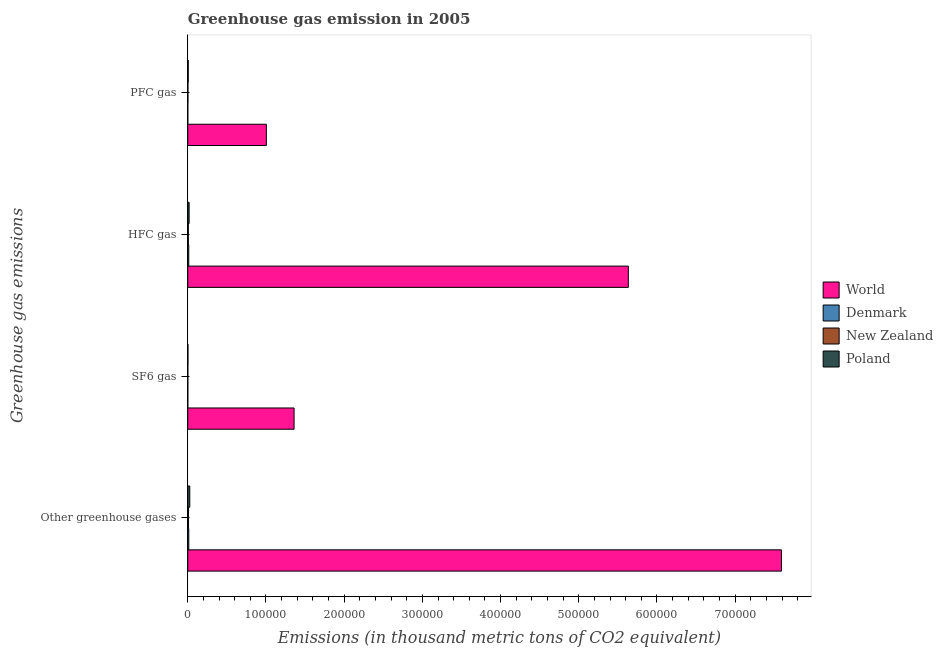How many groups of bars are there?
Offer a very short reply. 4. How many bars are there on the 4th tick from the top?
Provide a succinct answer. 4. What is the label of the 2nd group of bars from the top?
Offer a very short reply. HFC gas. What is the emission of sf6 gas in World?
Provide a succinct answer. 1.36e+05. Across all countries, what is the maximum emission of pfc gas?
Keep it short and to the point. 1.01e+05. Across all countries, what is the minimum emission of hfc gas?
Your answer should be compact. 721.7. In which country was the emission of hfc gas minimum?
Ensure brevity in your answer.  New Zealand. What is the total emission of hfc gas in the graph?
Give a very brief answer. 5.67e+05. What is the difference between the emission of greenhouse gases in New Zealand and that in Poland?
Make the answer very short. -1581.2. What is the difference between the emission of pfc gas in World and the emission of greenhouse gases in Denmark?
Offer a very short reply. 9.92e+04. What is the average emission of sf6 gas per country?
Your answer should be compact. 3.41e+04. What is the difference between the emission of greenhouse gases and emission of sf6 gas in Denmark?
Make the answer very short. 1271. What is the ratio of the emission of sf6 gas in Denmark to that in Poland?
Ensure brevity in your answer.  0.14. Is the emission of hfc gas in New Zealand less than that in Denmark?
Ensure brevity in your answer.  Yes. What is the difference between the highest and the second highest emission of pfc gas?
Provide a short and direct response. 9.99e+04. What is the difference between the highest and the lowest emission of sf6 gas?
Keep it short and to the point. 1.36e+05. In how many countries, is the emission of hfc gas greater than the average emission of hfc gas taken over all countries?
Keep it short and to the point. 1. Is the sum of the emission of greenhouse gases in New Zealand and Denmark greater than the maximum emission of hfc gas across all countries?
Your response must be concise. No. What does the 1st bar from the top in PFC gas represents?
Your response must be concise. Poland. How many bars are there?
Offer a very short reply. 16. Are all the bars in the graph horizontal?
Make the answer very short. Yes. Does the graph contain any zero values?
Make the answer very short. No. How many legend labels are there?
Make the answer very short. 4. How are the legend labels stacked?
Offer a terse response. Vertical. What is the title of the graph?
Your answer should be very brief. Greenhouse gas emission in 2005. Does "Sub-Saharan Africa (developing only)" appear as one of the legend labels in the graph?
Keep it short and to the point. No. What is the label or title of the X-axis?
Ensure brevity in your answer.  Emissions (in thousand metric tons of CO2 equivalent). What is the label or title of the Y-axis?
Your response must be concise. Greenhouse gas emissions. What is the Emissions (in thousand metric tons of CO2 equivalent) in World in Other greenhouse gases?
Your answer should be very brief. 7.59e+05. What is the Emissions (in thousand metric tons of CO2 equivalent) of Denmark in Other greenhouse gases?
Offer a very short reply. 1302.5. What is the Emissions (in thousand metric tons of CO2 equivalent) in New Zealand in Other greenhouse gases?
Make the answer very short. 966.7. What is the Emissions (in thousand metric tons of CO2 equivalent) of Poland in Other greenhouse gases?
Make the answer very short. 2547.9. What is the Emissions (in thousand metric tons of CO2 equivalent) of World in SF6 gas?
Make the answer very short. 1.36e+05. What is the Emissions (in thousand metric tons of CO2 equivalent) in Denmark in SF6 gas?
Provide a succinct answer. 31.5. What is the Emissions (in thousand metric tons of CO2 equivalent) of New Zealand in SF6 gas?
Your response must be concise. 53.4. What is the Emissions (in thousand metric tons of CO2 equivalent) in Poland in SF6 gas?
Your answer should be compact. 218.5. What is the Emissions (in thousand metric tons of CO2 equivalent) in World in HFC gas?
Ensure brevity in your answer.  5.63e+05. What is the Emissions (in thousand metric tons of CO2 equivalent) of Denmark in HFC gas?
Provide a succinct answer. 1249.5. What is the Emissions (in thousand metric tons of CO2 equivalent) in New Zealand in HFC gas?
Offer a terse response. 721.7. What is the Emissions (in thousand metric tons of CO2 equivalent) of Poland in HFC gas?
Your response must be concise. 1736.7. What is the Emissions (in thousand metric tons of CO2 equivalent) of World in PFC gas?
Ensure brevity in your answer.  1.01e+05. What is the Emissions (in thousand metric tons of CO2 equivalent) in New Zealand in PFC gas?
Ensure brevity in your answer.  191.6. What is the Emissions (in thousand metric tons of CO2 equivalent) in Poland in PFC gas?
Provide a succinct answer. 592.7. Across all Greenhouse gas emissions, what is the maximum Emissions (in thousand metric tons of CO2 equivalent) in World?
Make the answer very short. 7.59e+05. Across all Greenhouse gas emissions, what is the maximum Emissions (in thousand metric tons of CO2 equivalent) in Denmark?
Provide a short and direct response. 1302.5. Across all Greenhouse gas emissions, what is the maximum Emissions (in thousand metric tons of CO2 equivalent) in New Zealand?
Provide a succinct answer. 966.7. Across all Greenhouse gas emissions, what is the maximum Emissions (in thousand metric tons of CO2 equivalent) in Poland?
Provide a short and direct response. 2547.9. Across all Greenhouse gas emissions, what is the minimum Emissions (in thousand metric tons of CO2 equivalent) of World?
Give a very brief answer. 1.01e+05. Across all Greenhouse gas emissions, what is the minimum Emissions (in thousand metric tons of CO2 equivalent) of Denmark?
Offer a terse response. 21.5. Across all Greenhouse gas emissions, what is the minimum Emissions (in thousand metric tons of CO2 equivalent) in New Zealand?
Make the answer very short. 53.4. Across all Greenhouse gas emissions, what is the minimum Emissions (in thousand metric tons of CO2 equivalent) of Poland?
Make the answer very short. 218.5. What is the total Emissions (in thousand metric tons of CO2 equivalent) in World in the graph?
Make the answer very short. 1.56e+06. What is the total Emissions (in thousand metric tons of CO2 equivalent) in Denmark in the graph?
Keep it short and to the point. 2605. What is the total Emissions (in thousand metric tons of CO2 equivalent) of New Zealand in the graph?
Keep it short and to the point. 1933.4. What is the total Emissions (in thousand metric tons of CO2 equivalent) in Poland in the graph?
Offer a very short reply. 5095.8. What is the difference between the Emissions (in thousand metric tons of CO2 equivalent) in World in Other greenhouse gases and that in SF6 gas?
Ensure brevity in your answer.  6.23e+05. What is the difference between the Emissions (in thousand metric tons of CO2 equivalent) of Denmark in Other greenhouse gases and that in SF6 gas?
Offer a very short reply. 1271. What is the difference between the Emissions (in thousand metric tons of CO2 equivalent) of New Zealand in Other greenhouse gases and that in SF6 gas?
Your response must be concise. 913.3. What is the difference between the Emissions (in thousand metric tons of CO2 equivalent) of Poland in Other greenhouse gases and that in SF6 gas?
Offer a terse response. 2329.4. What is the difference between the Emissions (in thousand metric tons of CO2 equivalent) of World in Other greenhouse gases and that in HFC gas?
Provide a succinct answer. 1.96e+05. What is the difference between the Emissions (in thousand metric tons of CO2 equivalent) in New Zealand in Other greenhouse gases and that in HFC gas?
Make the answer very short. 245. What is the difference between the Emissions (in thousand metric tons of CO2 equivalent) in Poland in Other greenhouse gases and that in HFC gas?
Your answer should be compact. 811.2. What is the difference between the Emissions (in thousand metric tons of CO2 equivalent) of World in Other greenhouse gases and that in PFC gas?
Your answer should be compact. 6.59e+05. What is the difference between the Emissions (in thousand metric tons of CO2 equivalent) of Denmark in Other greenhouse gases and that in PFC gas?
Offer a very short reply. 1281. What is the difference between the Emissions (in thousand metric tons of CO2 equivalent) in New Zealand in Other greenhouse gases and that in PFC gas?
Provide a short and direct response. 775.1. What is the difference between the Emissions (in thousand metric tons of CO2 equivalent) of Poland in Other greenhouse gases and that in PFC gas?
Your response must be concise. 1955.2. What is the difference between the Emissions (in thousand metric tons of CO2 equivalent) of World in SF6 gas and that in HFC gas?
Your response must be concise. -4.27e+05. What is the difference between the Emissions (in thousand metric tons of CO2 equivalent) in Denmark in SF6 gas and that in HFC gas?
Provide a succinct answer. -1218. What is the difference between the Emissions (in thousand metric tons of CO2 equivalent) in New Zealand in SF6 gas and that in HFC gas?
Provide a succinct answer. -668.3. What is the difference between the Emissions (in thousand metric tons of CO2 equivalent) of Poland in SF6 gas and that in HFC gas?
Your answer should be compact. -1518.2. What is the difference between the Emissions (in thousand metric tons of CO2 equivalent) of World in SF6 gas and that in PFC gas?
Offer a very short reply. 3.54e+04. What is the difference between the Emissions (in thousand metric tons of CO2 equivalent) in New Zealand in SF6 gas and that in PFC gas?
Offer a very short reply. -138.2. What is the difference between the Emissions (in thousand metric tons of CO2 equivalent) of Poland in SF6 gas and that in PFC gas?
Your answer should be very brief. -374.2. What is the difference between the Emissions (in thousand metric tons of CO2 equivalent) of World in HFC gas and that in PFC gas?
Offer a very short reply. 4.63e+05. What is the difference between the Emissions (in thousand metric tons of CO2 equivalent) in Denmark in HFC gas and that in PFC gas?
Offer a very short reply. 1228. What is the difference between the Emissions (in thousand metric tons of CO2 equivalent) in New Zealand in HFC gas and that in PFC gas?
Your answer should be compact. 530.1. What is the difference between the Emissions (in thousand metric tons of CO2 equivalent) in Poland in HFC gas and that in PFC gas?
Offer a terse response. 1144. What is the difference between the Emissions (in thousand metric tons of CO2 equivalent) in World in Other greenhouse gases and the Emissions (in thousand metric tons of CO2 equivalent) in Denmark in SF6 gas?
Your response must be concise. 7.59e+05. What is the difference between the Emissions (in thousand metric tons of CO2 equivalent) of World in Other greenhouse gases and the Emissions (in thousand metric tons of CO2 equivalent) of New Zealand in SF6 gas?
Your answer should be compact. 7.59e+05. What is the difference between the Emissions (in thousand metric tons of CO2 equivalent) in World in Other greenhouse gases and the Emissions (in thousand metric tons of CO2 equivalent) in Poland in SF6 gas?
Ensure brevity in your answer.  7.59e+05. What is the difference between the Emissions (in thousand metric tons of CO2 equivalent) in Denmark in Other greenhouse gases and the Emissions (in thousand metric tons of CO2 equivalent) in New Zealand in SF6 gas?
Offer a very short reply. 1249.1. What is the difference between the Emissions (in thousand metric tons of CO2 equivalent) in Denmark in Other greenhouse gases and the Emissions (in thousand metric tons of CO2 equivalent) in Poland in SF6 gas?
Give a very brief answer. 1084. What is the difference between the Emissions (in thousand metric tons of CO2 equivalent) in New Zealand in Other greenhouse gases and the Emissions (in thousand metric tons of CO2 equivalent) in Poland in SF6 gas?
Provide a short and direct response. 748.2. What is the difference between the Emissions (in thousand metric tons of CO2 equivalent) of World in Other greenhouse gases and the Emissions (in thousand metric tons of CO2 equivalent) of Denmark in HFC gas?
Ensure brevity in your answer.  7.58e+05. What is the difference between the Emissions (in thousand metric tons of CO2 equivalent) of World in Other greenhouse gases and the Emissions (in thousand metric tons of CO2 equivalent) of New Zealand in HFC gas?
Your answer should be compact. 7.58e+05. What is the difference between the Emissions (in thousand metric tons of CO2 equivalent) of World in Other greenhouse gases and the Emissions (in thousand metric tons of CO2 equivalent) of Poland in HFC gas?
Make the answer very short. 7.57e+05. What is the difference between the Emissions (in thousand metric tons of CO2 equivalent) in Denmark in Other greenhouse gases and the Emissions (in thousand metric tons of CO2 equivalent) in New Zealand in HFC gas?
Your answer should be very brief. 580.8. What is the difference between the Emissions (in thousand metric tons of CO2 equivalent) in Denmark in Other greenhouse gases and the Emissions (in thousand metric tons of CO2 equivalent) in Poland in HFC gas?
Offer a terse response. -434.2. What is the difference between the Emissions (in thousand metric tons of CO2 equivalent) of New Zealand in Other greenhouse gases and the Emissions (in thousand metric tons of CO2 equivalent) of Poland in HFC gas?
Provide a short and direct response. -770. What is the difference between the Emissions (in thousand metric tons of CO2 equivalent) in World in Other greenhouse gases and the Emissions (in thousand metric tons of CO2 equivalent) in Denmark in PFC gas?
Provide a succinct answer. 7.59e+05. What is the difference between the Emissions (in thousand metric tons of CO2 equivalent) of World in Other greenhouse gases and the Emissions (in thousand metric tons of CO2 equivalent) of New Zealand in PFC gas?
Give a very brief answer. 7.59e+05. What is the difference between the Emissions (in thousand metric tons of CO2 equivalent) in World in Other greenhouse gases and the Emissions (in thousand metric tons of CO2 equivalent) in Poland in PFC gas?
Make the answer very short. 7.59e+05. What is the difference between the Emissions (in thousand metric tons of CO2 equivalent) in Denmark in Other greenhouse gases and the Emissions (in thousand metric tons of CO2 equivalent) in New Zealand in PFC gas?
Make the answer very short. 1110.9. What is the difference between the Emissions (in thousand metric tons of CO2 equivalent) of Denmark in Other greenhouse gases and the Emissions (in thousand metric tons of CO2 equivalent) of Poland in PFC gas?
Provide a succinct answer. 709.8. What is the difference between the Emissions (in thousand metric tons of CO2 equivalent) of New Zealand in Other greenhouse gases and the Emissions (in thousand metric tons of CO2 equivalent) of Poland in PFC gas?
Your response must be concise. 374. What is the difference between the Emissions (in thousand metric tons of CO2 equivalent) in World in SF6 gas and the Emissions (in thousand metric tons of CO2 equivalent) in Denmark in HFC gas?
Your answer should be compact. 1.35e+05. What is the difference between the Emissions (in thousand metric tons of CO2 equivalent) of World in SF6 gas and the Emissions (in thousand metric tons of CO2 equivalent) of New Zealand in HFC gas?
Offer a very short reply. 1.35e+05. What is the difference between the Emissions (in thousand metric tons of CO2 equivalent) of World in SF6 gas and the Emissions (in thousand metric tons of CO2 equivalent) of Poland in HFC gas?
Make the answer very short. 1.34e+05. What is the difference between the Emissions (in thousand metric tons of CO2 equivalent) in Denmark in SF6 gas and the Emissions (in thousand metric tons of CO2 equivalent) in New Zealand in HFC gas?
Make the answer very short. -690.2. What is the difference between the Emissions (in thousand metric tons of CO2 equivalent) of Denmark in SF6 gas and the Emissions (in thousand metric tons of CO2 equivalent) of Poland in HFC gas?
Ensure brevity in your answer.  -1705.2. What is the difference between the Emissions (in thousand metric tons of CO2 equivalent) of New Zealand in SF6 gas and the Emissions (in thousand metric tons of CO2 equivalent) of Poland in HFC gas?
Offer a terse response. -1683.3. What is the difference between the Emissions (in thousand metric tons of CO2 equivalent) in World in SF6 gas and the Emissions (in thousand metric tons of CO2 equivalent) in Denmark in PFC gas?
Ensure brevity in your answer.  1.36e+05. What is the difference between the Emissions (in thousand metric tons of CO2 equivalent) of World in SF6 gas and the Emissions (in thousand metric tons of CO2 equivalent) of New Zealand in PFC gas?
Your answer should be compact. 1.36e+05. What is the difference between the Emissions (in thousand metric tons of CO2 equivalent) of World in SF6 gas and the Emissions (in thousand metric tons of CO2 equivalent) of Poland in PFC gas?
Provide a succinct answer. 1.35e+05. What is the difference between the Emissions (in thousand metric tons of CO2 equivalent) in Denmark in SF6 gas and the Emissions (in thousand metric tons of CO2 equivalent) in New Zealand in PFC gas?
Your answer should be very brief. -160.1. What is the difference between the Emissions (in thousand metric tons of CO2 equivalent) in Denmark in SF6 gas and the Emissions (in thousand metric tons of CO2 equivalent) in Poland in PFC gas?
Offer a very short reply. -561.2. What is the difference between the Emissions (in thousand metric tons of CO2 equivalent) in New Zealand in SF6 gas and the Emissions (in thousand metric tons of CO2 equivalent) in Poland in PFC gas?
Offer a very short reply. -539.3. What is the difference between the Emissions (in thousand metric tons of CO2 equivalent) in World in HFC gas and the Emissions (in thousand metric tons of CO2 equivalent) in Denmark in PFC gas?
Your response must be concise. 5.63e+05. What is the difference between the Emissions (in thousand metric tons of CO2 equivalent) in World in HFC gas and the Emissions (in thousand metric tons of CO2 equivalent) in New Zealand in PFC gas?
Your answer should be compact. 5.63e+05. What is the difference between the Emissions (in thousand metric tons of CO2 equivalent) of World in HFC gas and the Emissions (in thousand metric tons of CO2 equivalent) of Poland in PFC gas?
Your response must be concise. 5.63e+05. What is the difference between the Emissions (in thousand metric tons of CO2 equivalent) of Denmark in HFC gas and the Emissions (in thousand metric tons of CO2 equivalent) of New Zealand in PFC gas?
Keep it short and to the point. 1057.9. What is the difference between the Emissions (in thousand metric tons of CO2 equivalent) of Denmark in HFC gas and the Emissions (in thousand metric tons of CO2 equivalent) of Poland in PFC gas?
Offer a very short reply. 656.8. What is the difference between the Emissions (in thousand metric tons of CO2 equivalent) of New Zealand in HFC gas and the Emissions (in thousand metric tons of CO2 equivalent) of Poland in PFC gas?
Give a very brief answer. 129. What is the average Emissions (in thousand metric tons of CO2 equivalent) of World per Greenhouse gas emissions?
Provide a short and direct response. 3.90e+05. What is the average Emissions (in thousand metric tons of CO2 equivalent) of Denmark per Greenhouse gas emissions?
Provide a succinct answer. 651.25. What is the average Emissions (in thousand metric tons of CO2 equivalent) of New Zealand per Greenhouse gas emissions?
Your answer should be very brief. 483.35. What is the average Emissions (in thousand metric tons of CO2 equivalent) of Poland per Greenhouse gas emissions?
Your answer should be very brief. 1273.95. What is the difference between the Emissions (in thousand metric tons of CO2 equivalent) of World and Emissions (in thousand metric tons of CO2 equivalent) of Denmark in Other greenhouse gases?
Provide a succinct answer. 7.58e+05. What is the difference between the Emissions (in thousand metric tons of CO2 equivalent) of World and Emissions (in thousand metric tons of CO2 equivalent) of New Zealand in Other greenhouse gases?
Provide a short and direct response. 7.58e+05. What is the difference between the Emissions (in thousand metric tons of CO2 equivalent) in World and Emissions (in thousand metric tons of CO2 equivalent) in Poland in Other greenhouse gases?
Offer a terse response. 7.57e+05. What is the difference between the Emissions (in thousand metric tons of CO2 equivalent) in Denmark and Emissions (in thousand metric tons of CO2 equivalent) in New Zealand in Other greenhouse gases?
Give a very brief answer. 335.8. What is the difference between the Emissions (in thousand metric tons of CO2 equivalent) in Denmark and Emissions (in thousand metric tons of CO2 equivalent) in Poland in Other greenhouse gases?
Give a very brief answer. -1245.4. What is the difference between the Emissions (in thousand metric tons of CO2 equivalent) of New Zealand and Emissions (in thousand metric tons of CO2 equivalent) of Poland in Other greenhouse gases?
Give a very brief answer. -1581.2. What is the difference between the Emissions (in thousand metric tons of CO2 equivalent) of World and Emissions (in thousand metric tons of CO2 equivalent) of Denmark in SF6 gas?
Offer a terse response. 1.36e+05. What is the difference between the Emissions (in thousand metric tons of CO2 equivalent) in World and Emissions (in thousand metric tons of CO2 equivalent) in New Zealand in SF6 gas?
Provide a succinct answer. 1.36e+05. What is the difference between the Emissions (in thousand metric tons of CO2 equivalent) in World and Emissions (in thousand metric tons of CO2 equivalent) in Poland in SF6 gas?
Provide a short and direct response. 1.36e+05. What is the difference between the Emissions (in thousand metric tons of CO2 equivalent) in Denmark and Emissions (in thousand metric tons of CO2 equivalent) in New Zealand in SF6 gas?
Your answer should be very brief. -21.9. What is the difference between the Emissions (in thousand metric tons of CO2 equivalent) of Denmark and Emissions (in thousand metric tons of CO2 equivalent) of Poland in SF6 gas?
Your response must be concise. -187. What is the difference between the Emissions (in thousand metric tons of CO2 equivalent) of New Zealand and Emissions (in thousand metric tons of CO2 equivalent) of Poland in SF6 gas?
Make the answer very short. -165.1. What is the difference between the Emissions (in thousand metric tons of CO2 equivalent) in World and Emissions (in thousand metric tons of CO2 equivalent) in Denmark in HFC gas?
Offer a very short reply. 5.62e+05. What is the difference between the Emissions (in thousand metric tons of CO2 equivalent) of World and Emissions (in thousand metric tons of CO2 equivalent) of New Zealand in HFC gas?
Keep it short and to the point. 5.63e+05. What is the difference between the Emissions (in thousand metric tons of CO2 equivalent) of World and Emissions (in thousand metric tons of CO2 equivalent) of Poland in HFC gas?
Your answer should be compact. 5.62e+05. What is the difference between the Emissions (in thousand metric tons of CO2 equivalent) in Denmark and Emissions (in thousand metric tons of CO2 equivalent) in New Zealand in HFC gas?
Offer a terse response. 527.8. What is the difference between the Emissions (in thousand metric tons of CO2 equivalent) of Denmark and Emissions (in thousand metric tons of CO2 equivalent) of Poland in HFC gas?
Provide a short and direct response. -487.2. What is the difference between the Emissions (in thousand metric tons of CO2 equivalent) in New Zealand and Emissions (in thousand metric tons of CO2 equivalent) in Poland in HFC gas?
Offer a terse response. -1015. What is the difference between the Emissions (in thousand metric tons of CO2 equivalent) in World and Emissions (in thousand metric tons of CO2 equivalent) in Denmark in PFC gas?
Make the answer very short. 1.00e+05. What is the difference between the Emissions (in thousand metric tons of CO2 equivalent) in World and Emissions (in thousand metric tons of CO2 equivalent) in New Zealand in PFC gas?
Make the answer very short. 1.00e+05. What is the difference between the Emissions (in thousand metric tons of CO2 equivalent) in World and Emissions (in thousand metric tons of CO2 equivalent) in Poland in PFC gas?
Your answer should be compact. 9.99e+04. What is the difference between the Emissions (in thousand metric tons of CO2 equivalent) in Denmark and Emissions (in thousand metric tons of CO2 equivalent) in New Zealand in PFC gas?
Your answer should be compact. -170.1. What is the difference between the Emissions (in thousand metric tons of CO2 equivalent) in Denmark and Emissions (in thousand metric tons of CO2 equivalent) in Poland in PFC gas?
Your answer should be compact. -571.2. What is the difference between the Emissions (in thousand metric tons of CO2 equivalent) of New Zealand and Emissions (in thousand metric tons of CO2 equivalent) of Poland in PFC gas?
Offer a very short reply. -401.1. What is the ratio of the Emissions (in thousand metric tons of CO2 equivalent) of World in Other greenhouse gases to that in SF6 gas?
Keep it short and to the point. 5.58. What is the ratio of the Emissions (in thousand metric tons of CO2 equivalent) in Denmark in Other greenhouse gases to that in SF6 gas?
Offer a terse response. 41.35. What is the ratio of the Emissions (in thousand metric tons of CO2 equivalent) in New Zealand in Other greenhouse gases to that in SF6 gas?
Your answer should be compact. 18.1. What is the ratio of the Emissions (in thousand metric tons of CO2 equivalent) in Poland in Other greenhouse gases to that in SF6 gas?
Make the answer very short. 11.66. What is the ratio of the Emissions (in thousand metric tons of CO2 equivalent) of World in Other greenhouse gases to that in HFC gas?
Offer a very short reply. 1.35. What is the ratio of the Emissions (in thousand metric tons of CO2 equivalent) of Denmark in Other greenhouse gases to that in HFC gas?
Your answer should be compact. 1.04. What is the ratio of the Emissions (in thousand metric tons of CO2 equivalent) of New Zealand in Other greenhouse gases to that in HFC gas?
Ensure brevity in your answer.  1.34. What is the ratio of the Emissions (in thousand metric tons of CO2 equivalent) in Poland in Other greenhouse gases to that in HFC gas?
Your response must be concise. 1.47. What is the ratio of the Emissions (in thousand metric tons of CO2 equivalent) in World in Other greenhouse gases to that in PFC gas?
Offer a terse response. 7.55. What is the ratio of the Emissions (in thousand metric tons of CO2 equivalent) of Denmark in Other greenhouse gases to that in PFC gas?
Offer a very short reply. 60.58. What is the ratio of the Emissions (in thousand metric tons of CO2 equivalent) in New Zealand in Other greenhouse gases to that in PFC gas?
Keep it short and to the point. 5.05. What is the ratio of the Emissions (in thousand metric tons of CO2 equivalent) in Poland in Other greenhouse gases to that in PFC gas?
Give a very brief answer. 4.3. What is the ratio of the Emissions (in thousand metric tons of CO2 equivalent) in World in SF6 gas to that in HFC gas?
Your answer should be compact. 0.24. What is the ratio of the Emissions (in thousand metric tons of CO2 equivalent) of Denmark in SF6 gas to that in HFC gas?
Offer a very short reply. 0.03. What is the ratio of the Emissions (in thousand metric tons of CO2 equivalent) of New Zealand in SF6 gas to that in HFC gas?
Ensure brevity in your answer.  0.07. What is the ratio of the Emissions (in thousand metric tons of CO2 equivalent) in Poland in SF6 gas to that in HFC gas?
Provide a short and direct response. 0.13. What is the ratio of the Emissions (in thousand metric tons of CO2 equivalent) in World in SF6 gas to that in PFC gas?
Give a very brief answer. 1.35. What is the ratio of the Emissions (in thousand metric tons of CO2 equivalent) in Denmark in SF6 gas to that in PFC gas?
Provide a succinct answer. 1.47. What is the ratio of the Emissions (in thousand metric tons of CO2 equivalent) in New Zealand in SF6 gas to that in PFC gas?
Your response must be concise. 0.28. What is the ratio of the Emissions (in thousand metric tons of CO2 equivalent) in Poland in SF6 gas to that in PFC gas?
Provide a succinct answer. 0.37. What is the ratio of the Emissions (in thousand metric tons of CO2 equivalent) of World in HFC gas to that in PFC gas?
Your answer should be very brief. 5.6. What is the ratio of the Emissions (in thousand metric tons of CO2 equivalent) of Denmark in HFC gas to that in PFC gas?
Provide a succinct answer. 58.12. What is the ratio of the Emissions (in thousand metric tons of CO2 equivalent) of New Zealand in HFC gas to that in PFC gas?
Keep it short and to the point. 3.77. What is the ratio of the Emissions (in thousand metric tons of CO2 equivalent) of Poland in HFC gas to that in PFC gas?
Provide a short and direct response. 2.93. What is the difference between the highest and the second highest Emissions (in thousand metric tons of CO2 equivalent) of World?
Keep it short and to the point. 1.96e+05. What is the difference between the highest and the second highest Emissions (in thousand metric tons of CO2 equivalent) in Denmark?
Provide a succinct answer. 53. What is the difference between the highest and the second highest Emissions (in thousand metric tons of CO2 equivalent) in New Zealand?
Keep it short and to the point. 245. What is the difference between the highest and the second highest Emissions (in thousand metric tons of CO2 equivalent) of Poland?
Keep it short and to the point. 811.2. What is the difference between the highest and the lowest Emissions (in thousand metric tons of CO2 equivalent) of World?
Your response must be concise. 6.59e+05. What is the difference between the highest and the lowest Emissions (in thousand metric tons of CO2 equivalent) of Denmark?
Offer a very short reply. 1281. What is the difference between the highest and the lowest Emissions (in thousand metric tons of CO2 equivalent) in New Zealand?
Ensure brevity in your answer.  913.3. What is the difference between the highest and the lowest Emissions (in thousand metric tons of CO2 equivalent) of Poland?
Your response must be concise. 2329.4. 